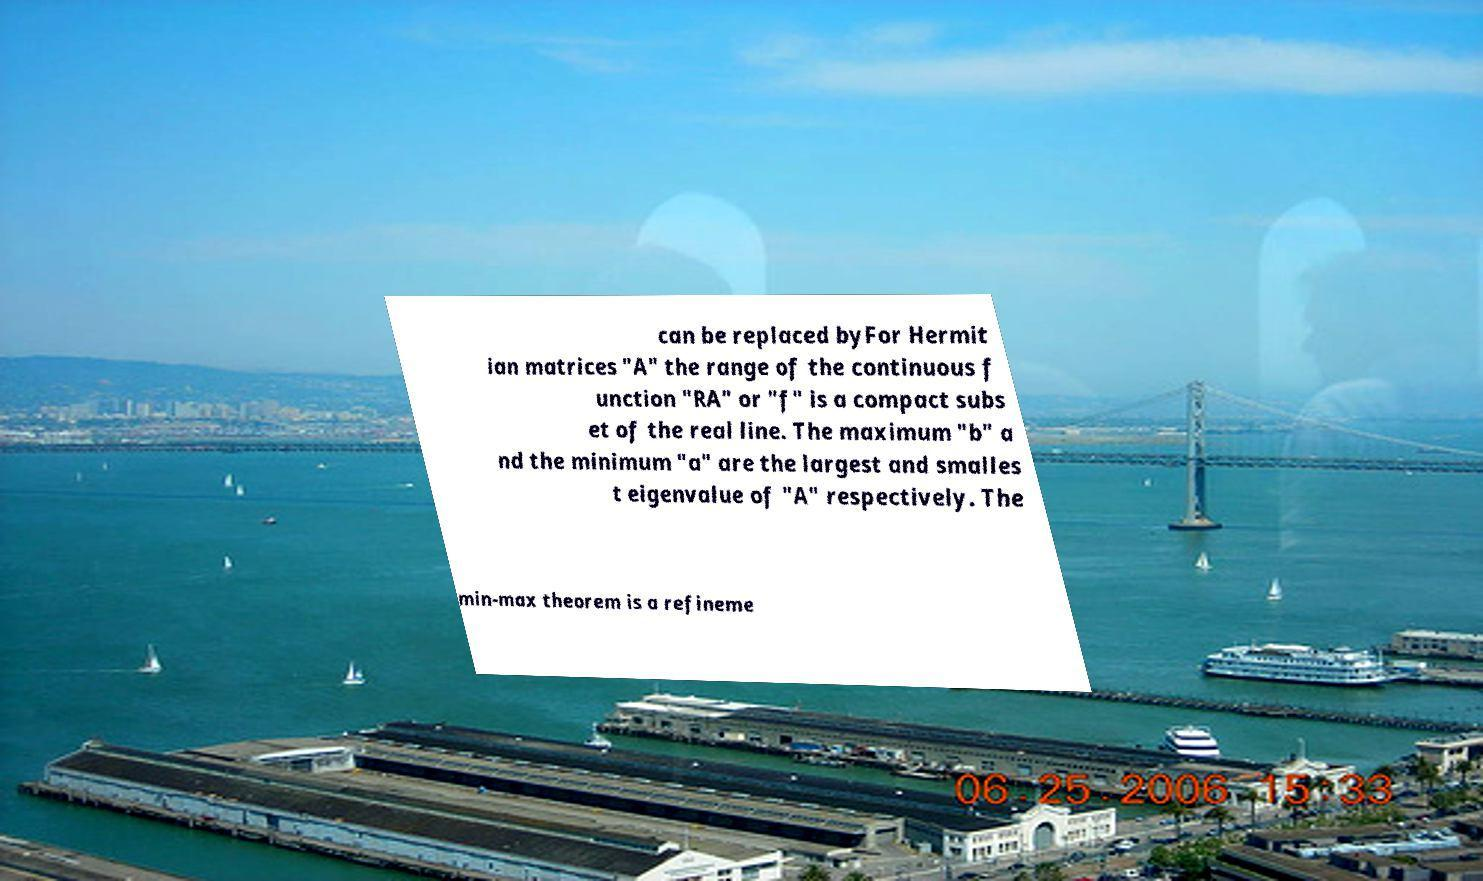Please identify and transcribe the text found in this image. can be replaced byFor Hermit ian matrices "A" the range of the continuous f unction "RA" or "f" is a compact subs et of the real line. The maximum "b" a nd the minimum "a" are the largest and smalles t eigenvalue of "A" respectively. The min-max theorem is a refineme 